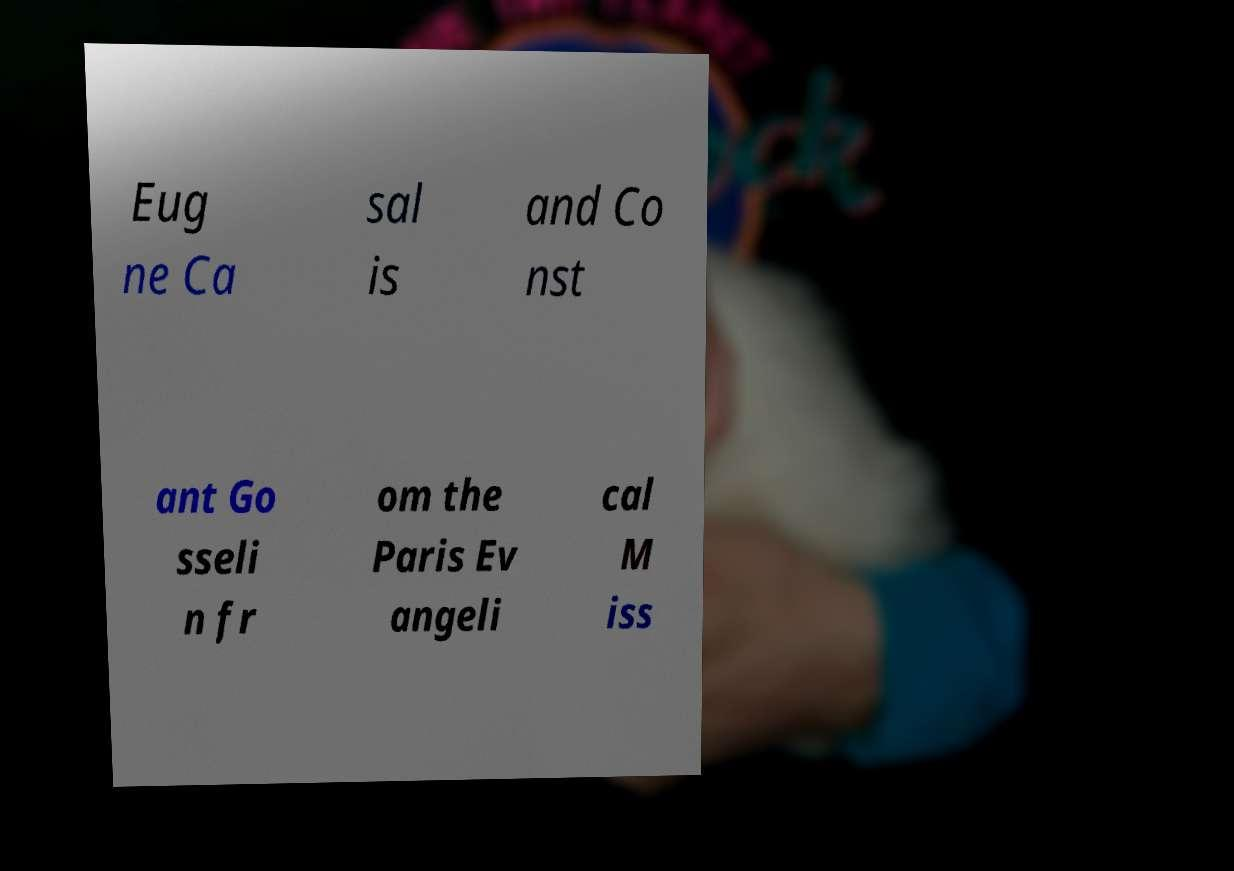Could you assist in decoding the text presented in this image and type it out clearly? Eug ne Ca sal is and Co nst ant Go sseli n fr om the Paris Ev angeli cal M iss 